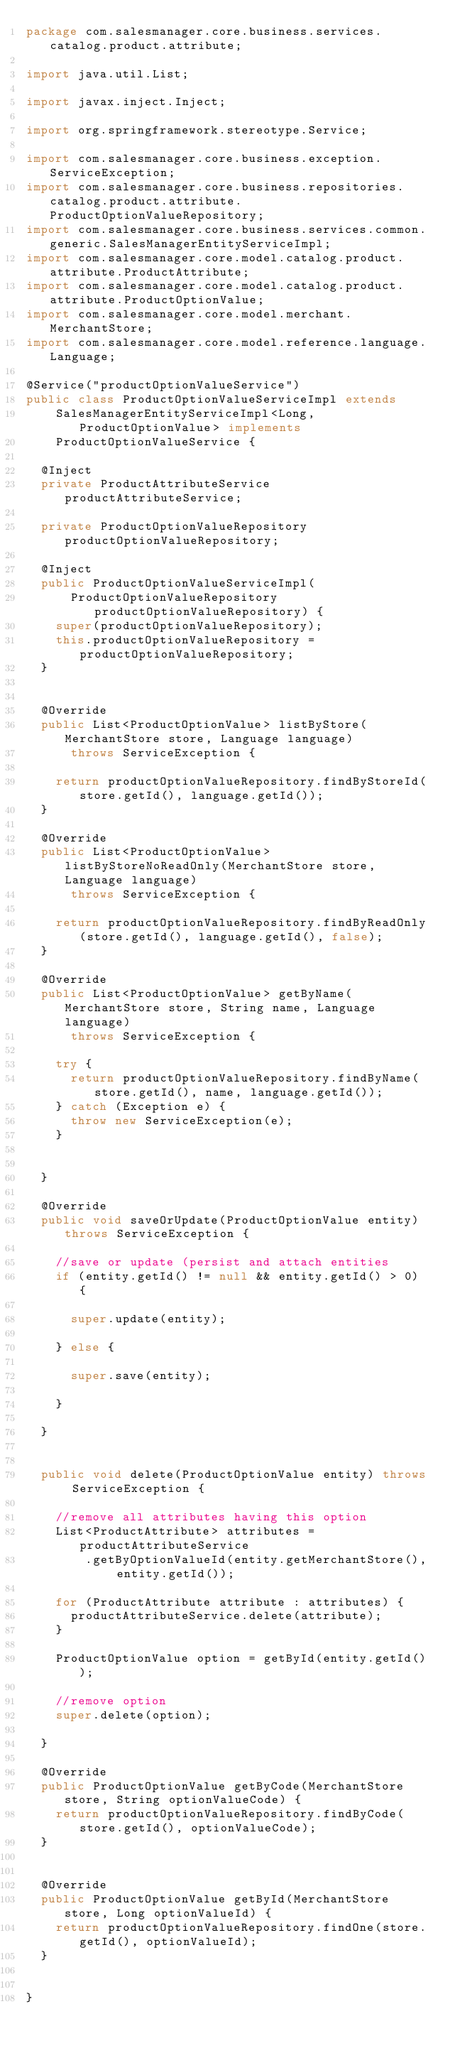<code> <loc_0><loc_0><loc_500><loc_500><_Java_>package com.salesmanager.core.business.services.catalog.product.attribute;

import java.util.List;

import javax.inject.Inject;

import org.springframework.stereotype.Service;

import com.salesmanager.core.business.exception.ServiceException;
import com.salesmanager.core.business.repositories.catalog.product.attribute.ProductOptionValueRepository;
import com.salesmanager.core.business.services.common.generic.SalesManagerEntityServiceImpl;
import com.salesmanager.core.model.catalog.product.attribute.ProductAttribute;
import com.salesmanager.core.model.catalog.product.attribute.ProductOptionValue;
import com.salesmanager.core.model.merchant.MerchantStore;
import com.salesmanager.core.model.reference.language.Language;

@Service("productOptionValueService")
public class ProductOptionValueServiceImpl extends
    SalesManagerEntityServiceImpl<Long, ProductOptionValue> implements
    ProductOptionValueService {

  @Inject
  private ProductAttributeService productAttributeService;

  private ProductOptionValueRepository productOptionValueRepository;

  @Inject
  public ProductOptionValueServiceImpl(
      ProductOptionValueRepository productOptionValueRepository) {
    super(productOptionValueRepository);
    this.productOptionValueRepository = productOptionValueRepository;
  }


  @Override
  public List<ProductOptionValue> listByStore(MerchantStore store, Language language)
      throws ServiceException {

    return productOptionValueRepository.findByStoreId(store.getId(), language.getId());
  }

  @Override
  public List<ProductOptionValue> listByStoreNoReadOnly(MerchantStore store, Language language)
      throws ServiceException {

    return productOptionValueRepository.findByReadOnly(store.getId(), language.getId(), false);
  }

  @Override
  public List<ProductOptionValue> getByName(MerchantStore store, String name, Language language)
      throws ServiceException {

    try {
      return productOptionValueRepository.findByName(store.getId(), name, language.getId());
    } catch (Exception e) {
      throw new ServiceException(e);
    }


  }

  @Override
  public void saveOrUpdate(ProductOptionValue entity) throws ServiceException {

    //save or update (persist and attach entities
    if (entity.getId() != null && entity.getId() > 0) {

      super.update(entity);

    } else {

      super.save(entity);

    }

  }


  public void delete(ProductOptionValue entity) throws ServiceException {

    //remove all attributes having this option
    List<ProductAttribute> attributes = productAttributeService
        .getByOptionValueId(entity.getMerchantStore(), entity.getId());

    for (ProductAttribute attribute : attributes) {
      productAttributeService.delete(attribute);
    }

    ProductOptionValue option = getById(entity.getId());

    //remove option
    super.delete(option);

  }

  @Override
  public ProductOptionValue getByCode(MerchantStore store, String optionValueCode) {
    return productOptionValueRepository.findByCode(store.getId(), optionValueCode);
  }


  @Override
  public ProductOptionValue getById(MerchantStore store, Long optionValueId) {
    return productOptionValueRepository.findOne(store.getId(), optionValueId);
  }


}
</code> 